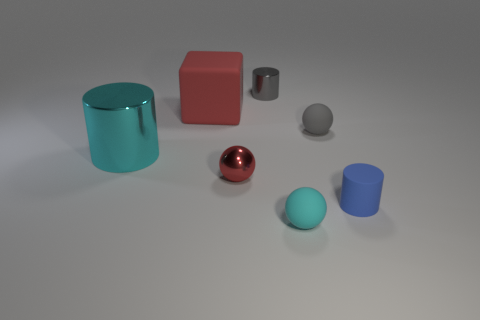Add 3 large rubber blocks. How many objects exist? 10 Subtract all blocks. How many objects are left? 6 Add 1 large red matte blocks. How many large red matte blocks are left? 2 Add 3 cyan objects. How many cyan objects exist? 5 Subtract 0 blue balls. How many objects are left? 7 Subtract all tiny rubber balls. Subtract all big cyan cylinders. How many objects are left? 4 